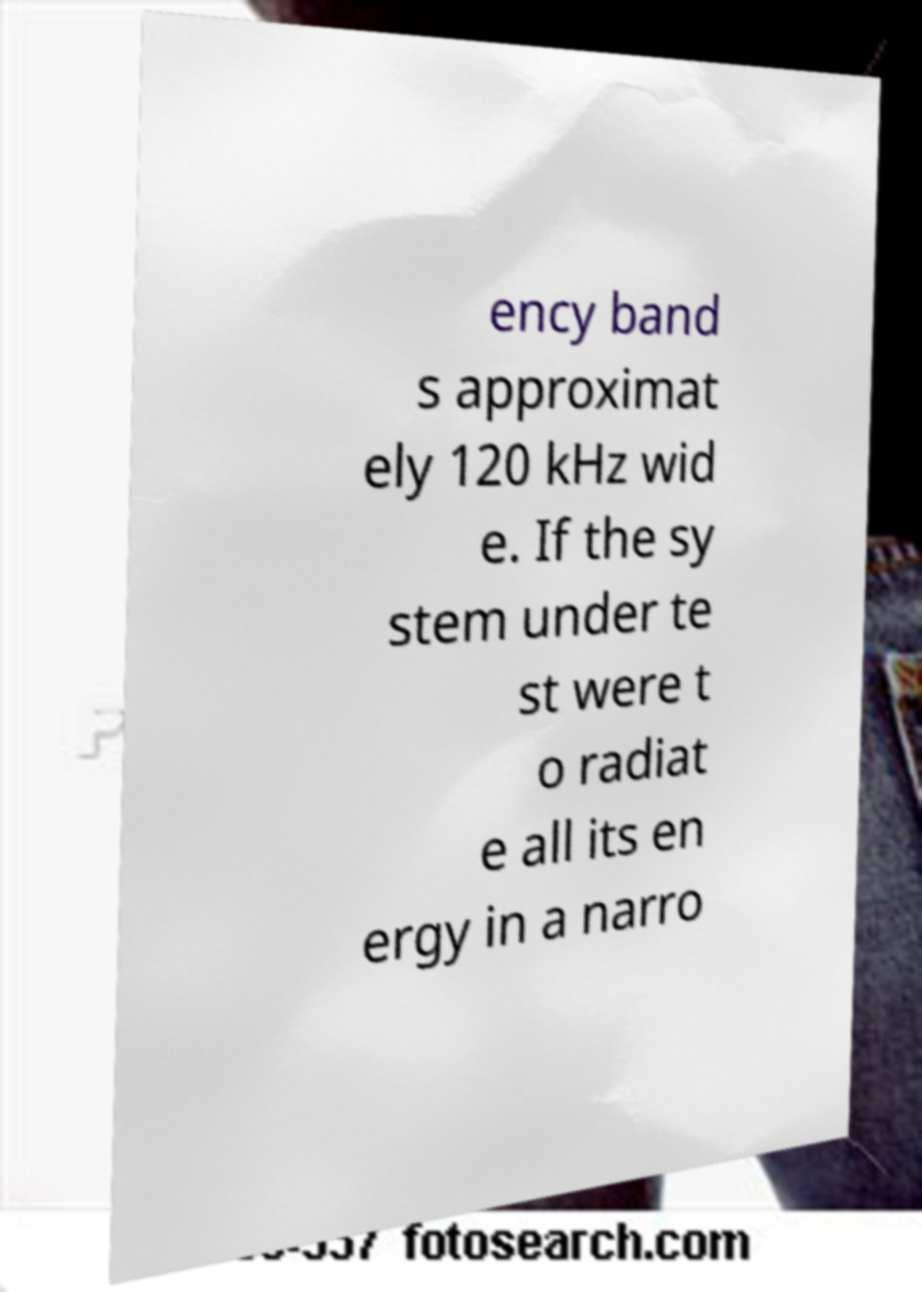Can you read and provide the text displayed in the image?This photo seems to have some interesting text. Can you extract and type it out for me? ency band s approximat ely 120 kHz wid e. If the sy stem under te st were t o radiat e all its en ergy in a narro 